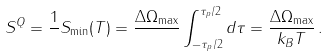<formula> <loc_0><loc_0><loc_500><loc_500>S ^ { Q } = \frac { 1 } { } S _ { \min } ( T ) = \frac { \Delta \Omega _ { \max } } { } \int _ { - \tau _ { p } / 2 } ^ { \tau _ { p } / 2 } d \tau = \frac { \Delta \Omega _ { \max } } { k _ { B } T } \, .</formula> 